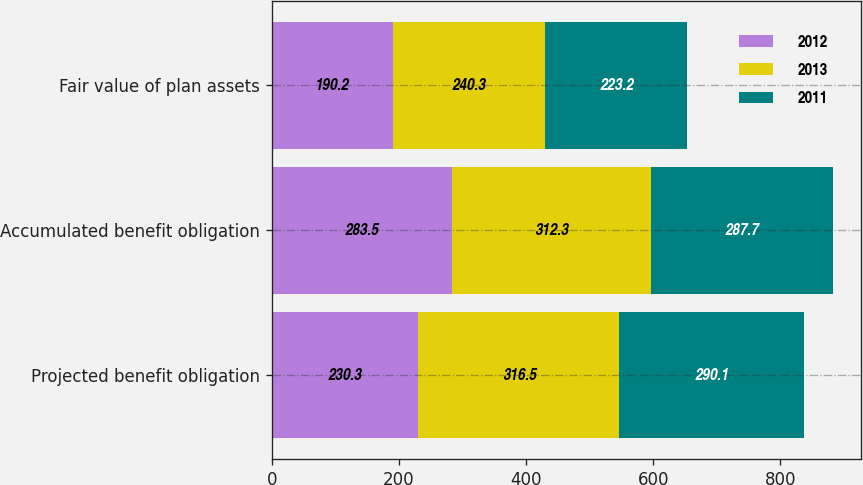Convert chart. <chart><loc_0><loc_0><loc_500><loc_500><stacked_bar_chart><ecel><fcel>Projected benefit obligation<fcel>Accumulated benefit obligation<fcel>Fair value of plan assets<nl><fcel>2012<fcel>230.3<fcel>283.5<fcel>190.2<nl><fcel>2013<fcel>316.5<fcel>312.3<fcel>240.3<nl><fcel>2011<fcel>290.1<fcel>287.7<fcel>223.2<nl></chart> 